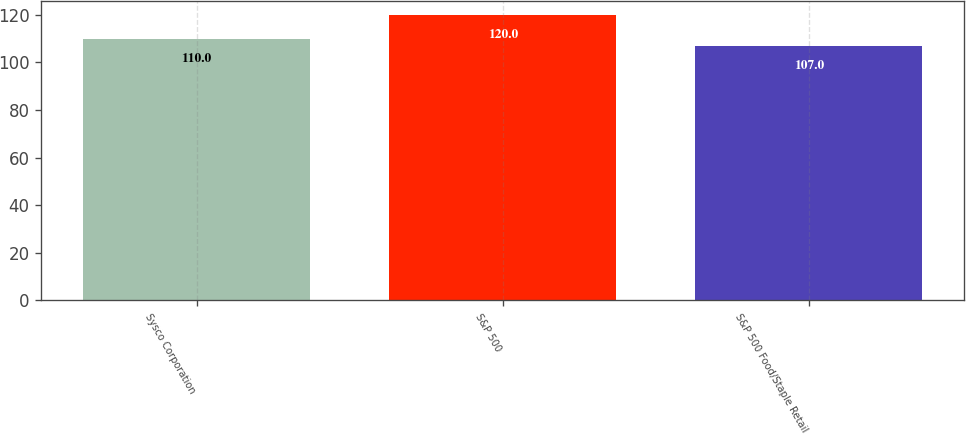Convert chart to OTSL. <chart><loc_0><loc_0><loc_500><loc_500><bar_chart><fcel>Sysco Corporation<fcel>S&P 500<fcel>S&P 500 Food/Staple Retail<nl><fcel>110<fcel>120<fcel>107<nl></chart> 